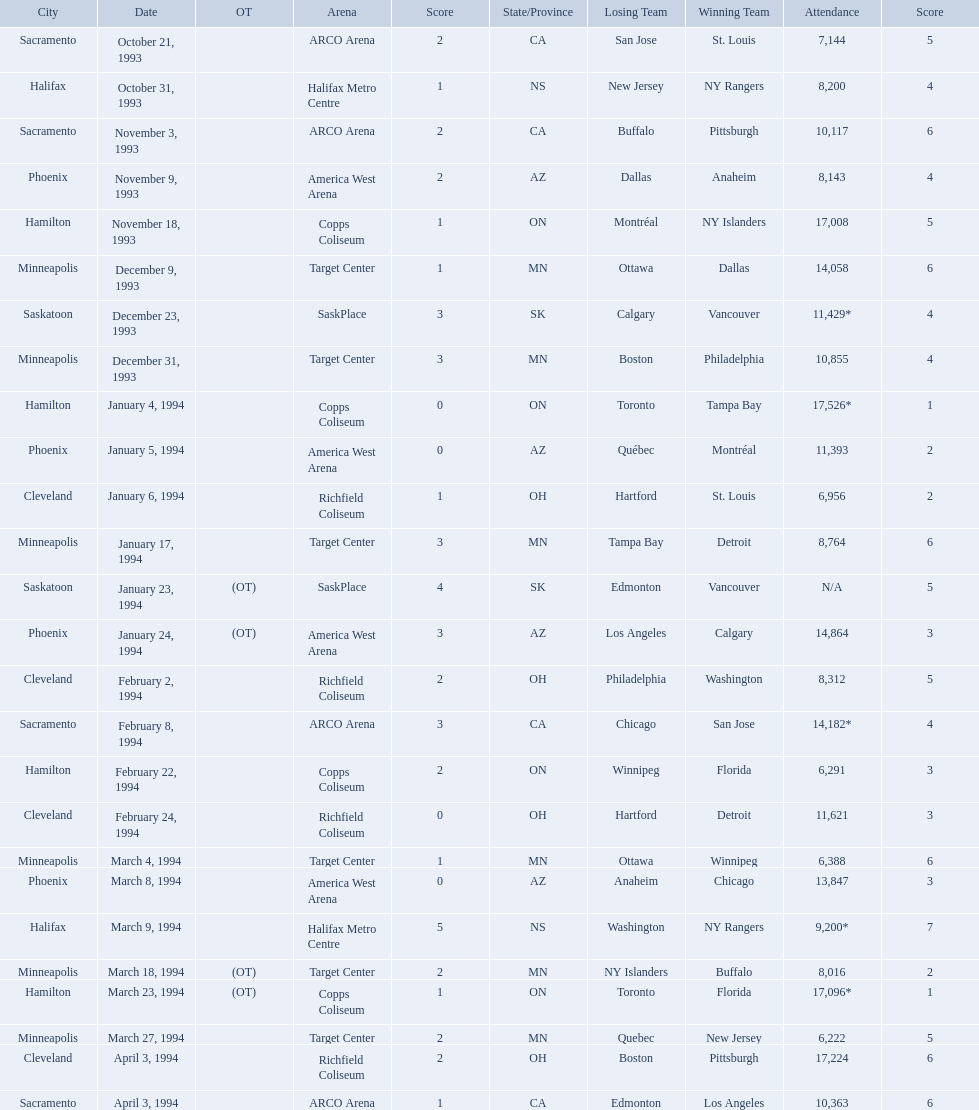Which dates saw the winning team score only one point? January 4, 1994, March 23, 1994. Of these two, which date had higher attendance? January 4, 1994. 